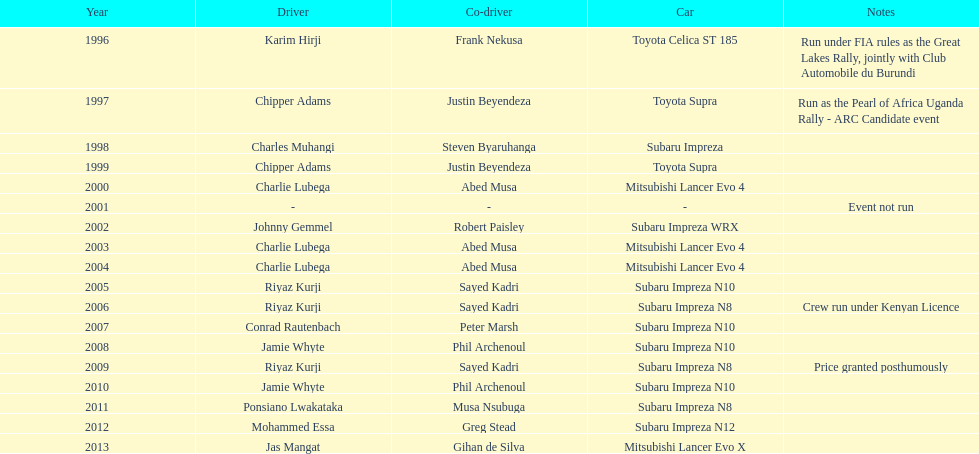Which driver won after ponsiano lwakataka? Mohammed Essa. 